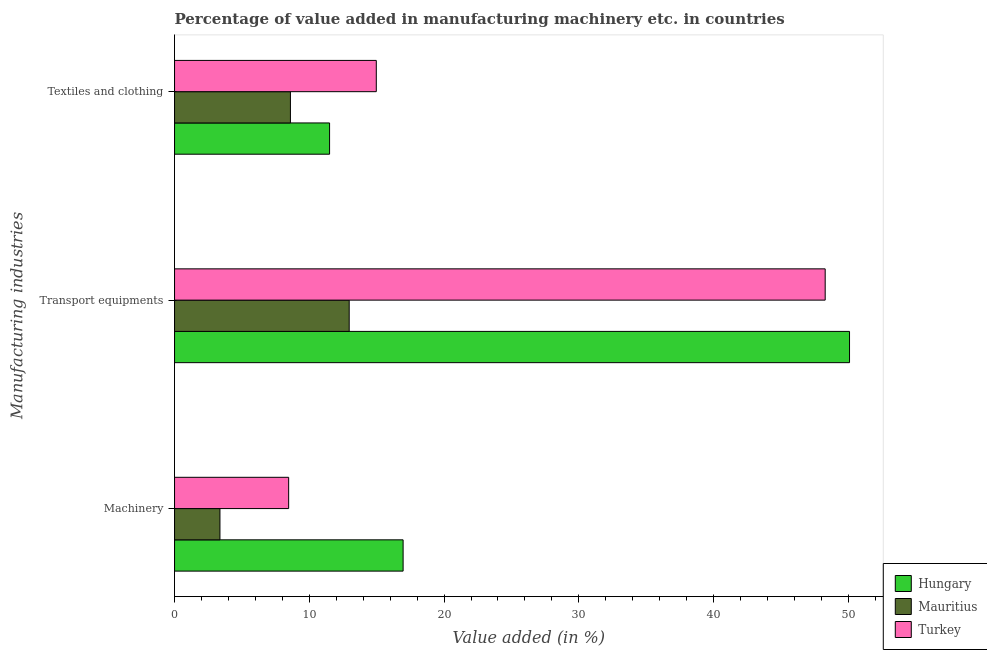Are the number of bars per tick equal to the number of legend labels?
Offer a very short reply. Yes. What is the label of the 2nd group of bars from the top?
Provide a short and direct response. Transport equipments. What is the value added in manufacturing textile and clothing in Turkey?
Your answer should be very brief. 14.97. Across all countries, what is the maximum value added in manufacturing transport equipments?
Keep it short and to the point. 50.09. Across all countries, what is the minimum value added in manufacturing transport equipments?
Provide a succinct answer. 12.96. In which country was the value added in manufacturing textile and clothing maximum?
Your answer should be very brief. Turkey. In which country was the value added in manufacturing transport equipments minimum?
Ensure brevity in your answer.  Mauritius. What is the total value added in manufacturing machinery in the graph?
Offer a very short reply. 28.8. What is the difference between the value added in manufacturing textile and clothing in Mauritius and that in Hungary?
Provide a succinct answer. -2.91. What is the difference between the value added in manufacturing textile and clothing in Turkey and the value added in manufacturing transport equipments in Mauritius?
Your answer should be compact. 2.01. What is the average value added in manufacturing transport equipments per country?
Provide a succinct answer. 37.11. What is the difference between the value added in manufacturing transport equipments and value added in manufacturing textile and clothing in Hungary?
Your response must be concise. 38.58. What is the ratio of the value added in manufacturing transport equipments in Mauritius to that in Hungary?
Provide a short and direct response. 0.26. What is the difference between the highest and the second highest value added in manufacturing machinery?
Provide a short and direct response. 8.49. What is the difference between the highest and the lowest value added in manufacturing transport equipments?
Offer a very short reply. 37.13. What does the 3rd bar from the top in Machinery represents?
Your answer should be very brief. Hungary. What does the 2nd bar from the bottom in Machinery represents?
Offer a terse response. Mauritius. How many countries are there in the graph?
Provide a short and direct response. 3. Are the values on the major ticks of X-axis written in scientific E-notation?
Make the answer very short. No. Does the graph contain any zero values?
Your answer should be very brief. No. What is the title of the graph?
Offer a very short reply. Percentage of value added in manufacturing machinery etc. in countries. What is the label or title of the X-axis?
Give a very brief answer. Value added (in %). What is the label or title of the Y-axis?
Your answer should be compact. Manufacturing industries. What is the Value added (in %) in Hungary in Machinery?
Offer a terse response. 16.96. What is the Value added (in %) of Mauritius in Machinery?
Your response must be concise. 3.37. What is the Value added (in %) of Turkey in Machinery?
Offer a very short reply. 8.47. What is the Value added (in %) of Hungary in Transport equipments?
Give a very brief answer. 50.09. What is the Value added (in %) of Mauritius in Transport equipments?
Keep it short and to the point. 12.96. What is the Value added (in %) of Turkey in Transport equipments?
Provide a short and direct response. 48.28. What is the Value added (in %) of Hungary in Textiles and clothing?
Make the answer very short. 11.5. What is the Value added (in %) of Mauritius in Textiles and clothing?
Your response must be concise. 8.6. What is the Value added (in %) of Turkey in Textiles and clothing?
Ensure brevity in your answer.  14.97. Across all Manufacturing industries, what is the maximum Value added (in %) in Hungary?
Offer a terse response. 50.09. Across all Manufacturing industries, what is the maximum Value added (in %) of Mauritius?
Ensure brevity in your answer.  12.96. Across all Manufacturing industries, what is the maximum Value added (in %) in Turkey?
Keep it short and to the point. 48.28. Across all Manufacturing industries, what is the minimum Value added (in %) in Hungary?
Provide a short and direct response. 11.5. Across all Manufacturing industries, what is the minimum Value added (in %) in Mauritius?
Your answer should be compact. 3.37. Across all Manufacturing industries, what is the minimum Value added (in %) in Turkey?
Your response must be concise. 8.47. What is the total Value added (in %) in Hungary in the graph?
Your answer should be compact. 78.55. What is the total Value added (in %) in Mauritius in the graph?
Your answer should be compact. 24.93. What is the total Value added (in %) of Turkey in the graph?
Your answer should be compact. 71.72. What is the difference between the Value added (in %) of Hungary in Machinery and that in Transport equipments?
Ensure brevity in your answer.  -33.13. What is the difference between the Value added (in %) in Mauritius in Machinery and that in Transport equipments?
Give a very brief answer. -9.59. What is the difference between the Value added (in %) in Turkey in Machinery and that in Transport equipments?
Give a very brief answer. -39.81. What is the difference between the Value added (in %) in Hungary in Machinery and that in Textiles and clothing?
Your answer should be very brief. 5.46. What is the difference between the Value added (in %) in Mauritius in Machinery and that in Textiles and clothing?
Provide a succinct answer. -5.23. What is the difference between the Value added (in %) in Turkey in Machinery and that in Textiles and clothing?
Ensure brevity in your answer.  -6.5. What is the difference between the Value added (in %) of Hungary in Transport equipments and that in Textiles and clothing?
Your answer should be very brief. 38.58. What is the difference between the Value added (in %) in Mauritius in Transport equipments and that in Textiles and clothing?
Your answer should be compact. 4.36. What is the difference between the Value added (in %) of Turkey in Transport equipments and that in Textiles and clothing?
Provide a succinct answer. 33.31. What is the difference between the Value added (in %) in Hungary in Machinery and the Value added (in %) in Mauritius in Transport equipments?
Make the answer very short. 4. What is the difference between the Value added (in %) in Hungary in Machinery and the Value added (in %) in Turkey in Transport equipments?
Your answer should be compact. -31.32. What is the difference between the Value added (in %) of Mauritius in Machinery and the Value added (in %) of Turkey in Transport equipments?
Provide a succinct answer. -44.91. What is the difference between the Value added (in %) of Hungary in Machinery and the Value added (in %) of Mauritius in Textiles and clothing?
Make the answer very short. 8.36. What is the difference between the Value added (in %) in Hungary in Machinery and the Value added (in %) in Turkey in Textiles and clothing?
Offer a terse response. 1.99. What is the difference between the Value added (in %) in Mauritius in Machinery and the Value added (in %) in Turkey in Textiles and clothing?
Provide a succinct answer. -11.6. What is the difference between the Value added (in %) of Hungary in Transport equipments and the Value added (in %) of Mauritius in Textiles and clothing?
Your answer should be compact. 41.49. What is the difference between the Value added (in %) in Hungary in Transport equipments and the Value added (in %) in Turkey in Textiles and clothing?
Your response must be concise. 35.12. What is the difference between the Value added (in %) of Mauritius in Transport equipments and the Value added (in %) of Turkey in Textiles and clothing?
Your answer should be very brief. -2.01. What is the average Value added (in %) in Hungary per Manufacturing industries?
Keep it short and to the point. 26.18. What is the average Value added (in %) in Mauritius per Manufacturing industries?
Your answer should be very brief. 8.31. What is the average Value added (in %) of Turkey per Manufacturing industries?
Offer a terse response. 23.91. What is the difference between the Value added (in %) in Hungary and Value added (in %) in Mauritius in Machinery?
Your response must be concise. 13.59. What is the difference between the Value added (in %) of Hungary and Value added (in %) of Turkey in Machinery?
Your response must be concise. 8.49. What is the difference between the Value added (in %) of Mauritius and Value added (in %) of Turkey in Machinery?
Ensure brevity in your answer.  -5.1. What is the difference between the Value added (in %) in Hungary and Value added (in %) in Mauritius in Transport equipments?
Your answer should be compact. 37.13. What is the difference between the Value added (in %) in Hungary and Value added (in %) in Turkey in Transport equipments?
Your response must be concise. 1.81. What is the difference between the Value added (in %) of Mauritius and Value added (in %) of Turkey in Transport equipments?
Offer a terse response. -35.32. What is the difference between the Value added (in %) of Hungary and Value added (in %) of Mauritius in Textiles and clothing?
Your response must be concise. 2.91. What is the difference between the Value added (in %) in Hungary and Value added (in %) in Turkey in Textiles and clothing?
Provide a succinct answer. -3.47. What is the difference between the Value added (in %) of Mauritius and Value added (in %) of Turkey in Textiles and clothing?
Provide a succinct answer. -6.37. What is the ratio of the Value added (in %) of Hungary in Machinery to that in Transport equipments?
Ensure brevity in your answer.  0.34. What is the ratio of the Value added (in %) in Mauritius in Machinery to that in Transport equipments?
Make the answer very short. 0.26. What is the ratio of the Value added (in %) of Turkey in Machinery to that in Transport equipments?
Offer a very short reply. 0.18. What is the ratio of the Value added (in %) of Hungary in Machinery to that in Textiles and clothing?
Your answer should be compact. 1.47. What is the ratio of the Value added (in %) in Mauritius in Machinery to that in Textiles and clothing?
Offer a terse response. 0.39. What is the ratio of the Value added (in %) in Turkey in Machinery to that in Textiles and clothing?
Your response must be concise. 0.57. What is the ratio of the Value added (in %) of Hungary in Transport equipments to that in Textiles and clothing?
Ensure brevity in your answer.  4.35. What is the ratio of the Value added (in %) of Mauritius in Transport equipments to that in Textiles and clothing?
Make the answer very short. 1.51. What is the ratio of the Value added (in %) in Turkey in Transport equipments to that in Textiles and clothing?
Provide a short and direct response. 3.23. What is the difference between the highest and the second highest Value added (in %) in Hungary?
Your answer should be very brief. 33.13. What is the difference between the highest and the second highest Value added (in %) of Mauritius?
Your answer should be compact. 4.36. What is the difference between the highest and the second highest Value added (in %) of Turkey?
Your answer should be compact. 33.31. What is the difference between the highest and the lowest Value added (in %) in Hungary?
Your answer should be very brief. 38.58. What is the difference between the highest and the lowest Value added (in %) in Mauritius?
Give a very brief answer. 9.59. What is the difference between the highest and the lowest Value added (in %) in Turkey?
Give a very brief answer. 39.81. 